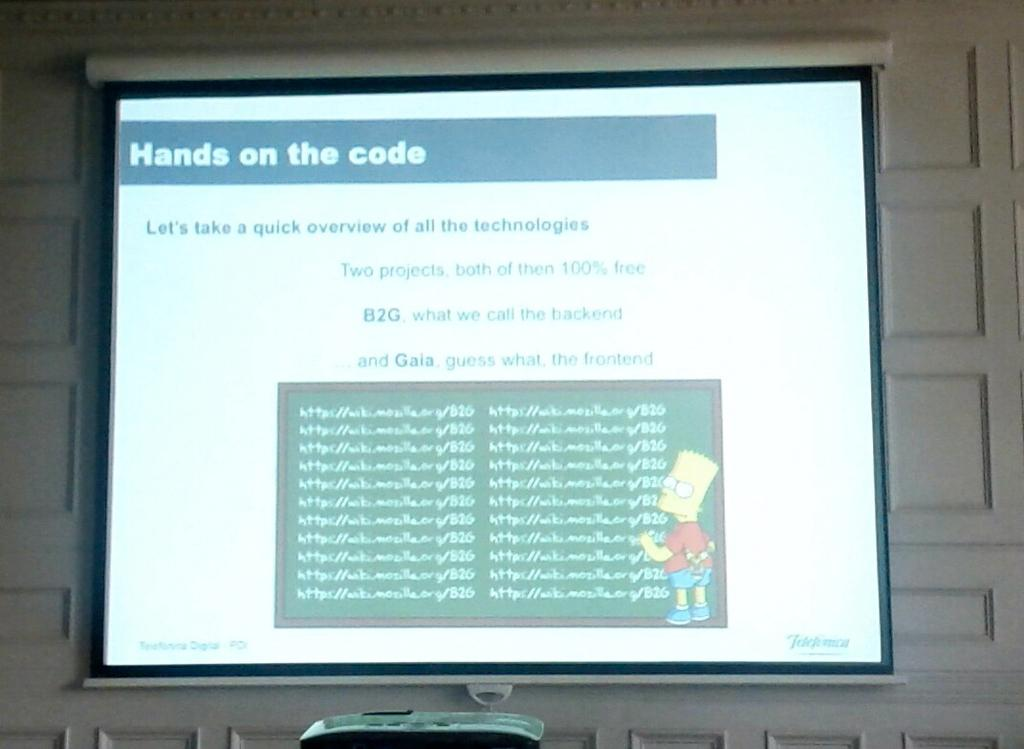<image>
Describe the image concisely. Bart Simpson is teaching coding in a slideshow. 